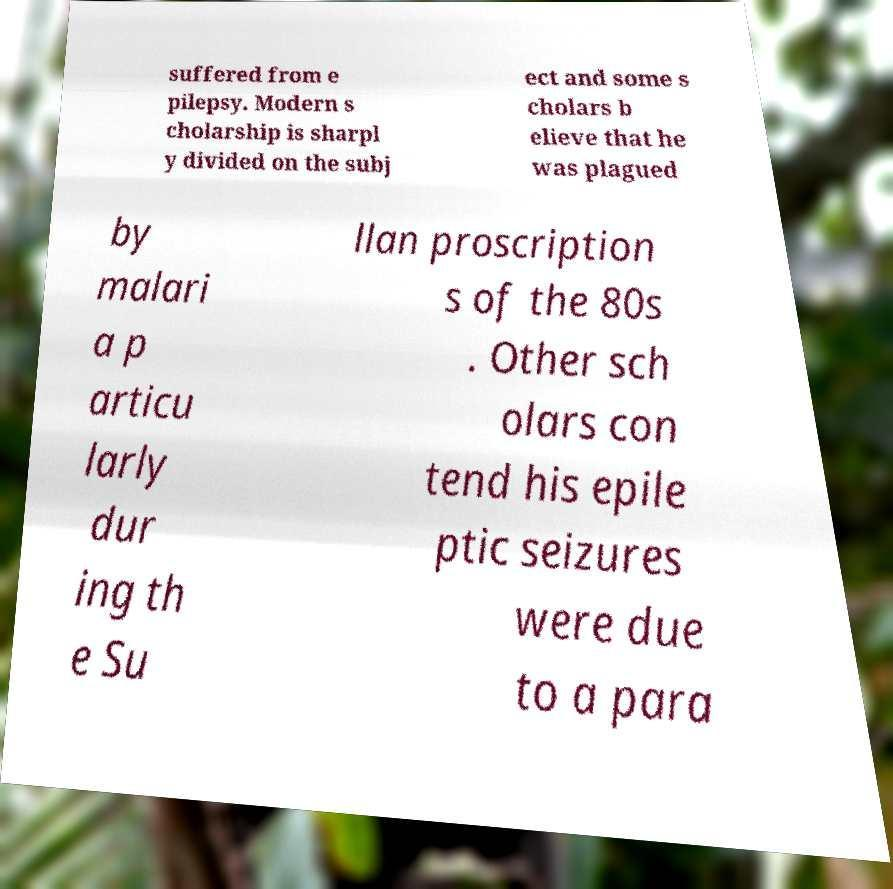There's text embedded in this image that I need extracted. Can you transcribe it verbatim? suffered from e pilepsy. Modern s cholarship is sharpl y divided on the subj ect and some s cholars b elieve that he was plagued by malari a p articu larly dur ing th e Su llan proscription s of the 80s . Other sch olars con tend his epile ptic seizures were due to a para 